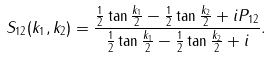Convert formula to latex. <formula><loc_0><loc_0><loc_500><loc_500>S _ { 1 2 } ( k _ { 1 } , k _ { 2 } ) = \frac { \frac { 1 } { 2 } \tan \frac { k _ { 1 } } 2 - \frac { 1 } { 2 } \tan \frac { k _ { 2 } } 2 + i P _ { 1 2 } } { \frac { 1 } { 2 } \tan \frac { k _ { 1 } } 2 - \frac { 1 } { 2 } \tan \frac { k _ { 2 } } 2 + i } .</formula> 